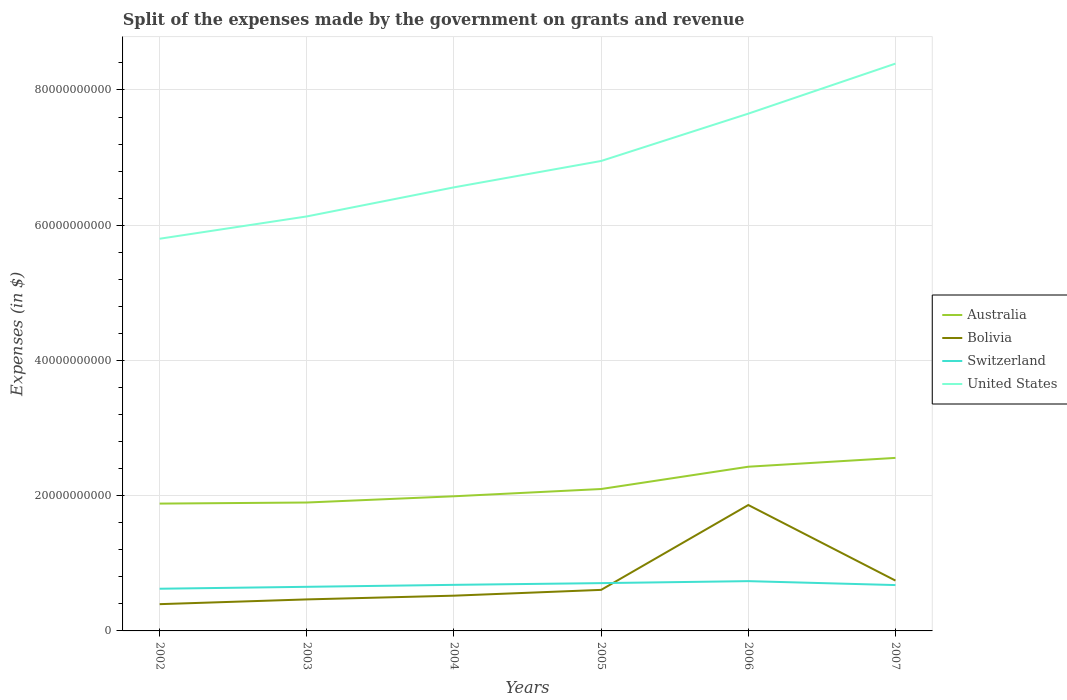Is the number of lines equal to the number of legend labels?
Provide a succinct answer. Yes. Across all years, what is the maximum expenses made by the government on grants and revenue in Switzerland?
Keep it short and to the point. 6.24e+09. What is the total expenses made by the government on grants and revenue in Switzerland in the graph?
Offer a terse response. -8.38e+08. What is the difference between the highest and the second highest expenses made by the government on grants and revenue in Australia?
Provide a short and direct response. 6.76e+09. Is the expenses made by the government on grants and revenue in Australia strictly greater than the expenses made by the government on grants and revenue in Bolivia over the years?
Give a very brief answer. No. How many years are there in the graph?
Offer a terse response. 6. Does the graph contain any zero values?
Give a very brief answer. No. Where does the legend appear in the graph?
Keep it short and to the point. Center right. How many legend labels are there?
Keep it short and to the point. 4. How are the legend labels stacked?
Make the answer very short. Vertical. What is the title of the graph?
Provide a succinct answer. Split of the expenses made by the government on grants and revenue. What is the label or title of the X-axis?
Offer a terse response. Years. What is the label or title of the Y-axis?
Provide a succinct answer. Expenses (in $). What is the Expenses (in $) in Australia in 2002?
Keep it short and to the point. 1.88e+1. What is the Expenses (in $) of Bolivia in 2002?
Provide a short and direct response. 3.96e+09. What is the Expenses (in $) of Switzerland in 2002?
Your answer should be very brief. 6.24e+09. What is the Expenses (in $) of United States in 2002?
Give a very brief answer. 5.80e+1. What is the Expenses (in $) in Australia in 2003?
Give a very brief answer. 1.90e+1. What is the Expenses (in $) of Bolivia in 2003?
Keep it short and to the point. 4.66e+09. What is the Expenses (in $) of Switzerland in 2003?
Your answer should be very brief. 6.52e+09. What is the Expenses (in $) in United States in 2003?
Give a very brief answer. 6.13e+1. What is the Expenses (in $) of Australia in 2004?
Provide a short and direct response. 1.99e+1. What is the Expenses (in $) in Bolivia in 2004?
Make the answer very short. 5.21e+09. What is the Expenses (in $) in Switzerland in 2004?
Make the answer very short. 6.81e+09. What is the Expenses (in $) of United States in 2004?
Provide a short and direct response. 6.56e+1. What is the Expenses (in $) of Australia in 2005?
Provide a succinct answer. 2.10e+1. What is the Expenses (in $) in Bolivia in 2005?
Keep it short and to the point. 6.07e+09. What is the Expenses (in $) in Switzerland in 2005?
Your answer should be very brief. 7.07e+09. What is the Expenses (in $) of United States in 2005?
Your response must be concise. 6.95e+1. What is the Expenses (in $) in Australia in 2006?
Provide a succinct answer. 2.43e+1. What is the Expenses (in $) in Bolivia in 2006?
Ensure brevity in your answer.  1.86e+1. What is the Expenses (in $) in Switzerland in 2006?
Your response must be concise. 7.36e+09. What is the Expenses (in $) of United States in 2006?
Keep it short and to the point. 7.65e+1. What is the Expenses (in $) in Australia in 2007?
Provide a short and direct response. 2.56e+1. What is the Expenses (in $) of Bolivia in 2007?
Provide a short and direct response. 7.44e+09. What is the Expenses (in $) of Switzerland in 2007?
Give a very brief answer. 6.78e+09. What is the Expenses (in $) in United States in 2007?
Ensure brevity in your answer.  8.39e+1. Across all years, what is the maximum Expenses (in $) of Australia?
Offer a very short reply. 2.56e+1. Across all years, what is the maximum Expenses (in $) in Bolivia?
Keep it short and to the point. 1.86e+1. Across all years, what is the maximum Expenses (in $) of Switzerland?
Ensure brevity in your answer.  7.36e+09. Across all years, what is the maximum Expenses (in $) in United States?
Offer a terse response. 8.39e+1. Across all years, what is the minimum Expenses (in $) in Australia?
Ensure brevity in your answer.  1.88e+1. Across all years, what is the minimum Expenses (in $) in Bolivia?
Your answer should be very brief. 3.96e+09. Across all years, what is the minimum Expenses (in $) of Switzerland?
Your response must be concise. 6.24e+09. Across all years, what is the minimum Expenses (in $) in United States?
Keep it short and to the point. 5.80e+1. What is the total Expenses (in $) in Australia in the graph?
Make the answer very short. 1.29e+11. What is the total Expenses (in $) in Bolivia in the graph?
Your answer should be compact. 4.60e+1. What is the total Expenses (in $) of Switzerland in the graph?
Ensure brevity in your answer.  4.08e+1. What is the total Expenses (in $) in United States in the graph?
Your answer should be compact. 4.15e+11. What is the difference between the Expenses (in $) of Australia in 2002 and that in 2003?
Your answer should be very brief. -1.58e+08. What is the difference between the Expenses (in $) of Bolivia in 2002 and that in 2003?
Provide a succinct answer. -7.02e+08. What is the difference between the Expenses (in $) of Switzerland in 2002 and that in 2003?
Offer a very short reply. -2.84e+08. What is the difference between the Expenses (in $) in United States in 2002 and that in 2003?
Provide a succinct answer. -3.30e+09. What is the difference between the Expenses (in $) of Australia in 2002 and that in 2004?
Give a very brief answer. -1.08e+09. What is the difference between the Expenses (in $) of Bolivia in 2002 and that in 2004?
Provide a short and direct response. -1.26e+09. What is the difference between the Expenses (in $) in Switzerland in 2002 and that in 2004?
Your response must be concise. -5.74e+08. What is the difference between the Expenses (in $) of United States in 2002 and that in 2004?
Provide a short and direct response. -7.60e+09. What is the difference between the Expenses (in $) of Australia in 2002 and that in 2005?
Make the answer very short. -2.16e+09. What is the difference between the Expenses (in $) of Bolivia in 2002 and that in 2005?
Keep it short and to the point. -2.11e+09. What is the difference between the Expenses (in $) in Switzerland in 2002 and that in 2005?
Keep it short and to the point. -8.30e+08. What is the difference between the Expenses (in $) of United States in 2002 and that in 2005?
Provide a succinct answer. -1.15e+1. What is the difference between the Expenses (in $) of Australia in 2002 and that in 2006?
Provide a succinct answer. -5.45e+09. What is the difference between the Expenses (in $) in Bolivia in 2002 and that in 2006?
Make the answer very short. -1.47e+1. What is the difference between the Expenses (in $) of Switzerland in 2002 and that in 2006?
Offer a terse response. -1.12e+09. What is the difference between the Expenses (in $) of United States in 2002 and that in 2006?
Provide a short and direct response. -1.85e+1. What is the difference between the Expenses (in $) of Australia in 2002 and that in 2007?
Ensure brevity in your answer.  -6.76e+09. What is the difference between the Expenses (in $) in Bolivia in 2002 and that in 2007?
Offer a very short reply. -3.48e+09. What is the difference between the Expenses (in $) in Switzerland in 2002 and that in 2007?
Offer a very short reply. -5.41e+08. What is the difference between the Expenses (in $) in United States in 2002 and that in 2007?
Your response must be concise. -2.59e+1. What is the difference between the Expenses (in $) in Australia in 2003 and that in 2004?
Keep it short and to the point. -9.24e+08. What is the difference between the Expenses (in $) of Bolivia in 2003 and that in 2004?
Make the answer very short. -5.53e+08. What is the difference between the Expenses (in $) of Switzerland in 2003 and that in 2004?
Your answer should be very brief. -2.91e+08. What is the difference between the Expenses (in $) of United States in 2003 and that in 2004?
Give a very brief answer. -4.30e+09. What is the difference between the Expenses (in $) in Australia in 2003 and that in 2005?
Make the answer very short. -2.00e+09. What is the difference between the Expenses (in $) in Bolivia in 2003 and that in 2005?
Your answer should be compact. -1.41e+09. What is the difference between the Expenses (in $) in Switzerland in 2003 and that in 2005?
Your response must be concise. -5.46e+08. What is the difference between the Expenses (in $) in United States in 2003 and that in 2005?
Your answer should be compact. -8.20e+09. What is the difference between the Expenses (in $) of Australia in 2003 and that in 2006?
Offer a very short reply. -5.29e+09. What is the difference between the Expenses (in $) of Bolivia in 2003 and that in 2006?
Your response must be concise. -1.40e+1. What is the difference between the Expenses (in $) of Switzerland in 2003 and that in 2006?
Your answer should be compact. -8.38e+08. What is the difference between the Expenses (in $) of United States in 2003 and that in 2006?
Offer a very short reply. -1.52e+1. What is the difference between the Expenses (in $) of Australia in 2003 and that in 2007?
Make the answer very short. -6.60e+09. What is the difference between the Expenses (in $) of Bolivia in 2003 and that in 2007?
Give a very brief answer. -2.78e+09. What is the difference between the Expenses (in $) in Switzerland in 2003 and that in 2007?
Provide a succinct answer. -2.58e+08. What is the difference between the Expenses (in $) in United States in 2003 and that in 2007?
Offer a terse response. -2.26e+1. What is the difference between the Expenses (in $) in Australia in 2004 and that in 2005?
Your response must be concise. -1.07e+09. What is the difference between the Expenses (in $) of Bolivia in 2004 and that in 2005?
Your response must be concise. -8.57e+08. What is the difference between the Expenses (in $) of Switzerland in 2004 and that in 2005?
Make the answer very short. -2.56e+08. What is the difference between the Expenses (in $) of United States in 2004 and that in 2005?
Your answer should be compact. -3.90e+09. What is the difference between the Expenses (in $) of Australia in 2004 and that in 2006?
Offer a terse response. -4.37e+09. What is the difference between the Expenses (in $) in Bolivia in 2004 and that in 2006?
Provide a succinct answer. -1.34e+1. What is the difference between the Expenses (in $) in Switzerland in 2004 and that in 2006?
Ensure brevity in your answer.  -5.47e+08. What is the difference between the Expenses (in $) in United States in 2004 and that in 2006?
Your answer should be compact. -1.09e+1. What is the difference between the Expenses (in $) of Australia in 2004 and that in 2007?
Give a very brief answer. -5.68e+09. What is the difference between the Expenses (in $) of Bolivia in 2004 and that in 2007?
Offer a terse response. -2.23e+09. What is the difference between the Expenses (in $) in Switzerland in 2004 and that in 2007?
Your response must be concise. 3.30e+07. What is the difference between the Expenses (in $) in United States in 2004 and that in 2007?
Offer a very short reply. -1.83e+1. What is the difference between the Expenses (in $) in Australia in 2005 and that in 2006?
Offer a terse response. -3.30e+09. What is the difference between the Expenses (in $) in Bolivia in 2005 and that in 2006?
Your answer should be very brief. -1.25e+1. What is the difference between the Expenses (in $) of Switzerland in 2005 and that in 2006?
Make the answer very short. -2.92e+08. What is the difference between the Expenses (in $) of United States in 2005 and that in 2006?
Ensure brevity in your answer.  -7.00e+09. What is the difference between the Expenses (in $) in Australia in 2005 and that in 2007?
Your response must be concise. -4.60e+09. What is the difference between the Expenses (in $) in Bolivia in 2005 and that in 2007?
Ensure brevity in your answer.  -1.37e+09. What is the difference between the Expenses (in $) of Switzerland in 2005 and that in 2007?
Keep it short and to the point. 2.89e+08. What is the difference between the Expenses (in $) of United States in 2005 and that in 2007?
Provide a succinct answer. -1.44e+1. What is the difference between the Expenses (in $) in Australia in 2006 and that in 2007?
Provide a short and direct response. -1.31e+09. What is the difference between the Expenses (in $) of Bolivia in 2006 and that in 2007?
Give a very brief answer. 1.12e+1. What is the difference between the Expenses (in $) in Switzerland in 2006 and that in 2007?
Offer a very short reply. 5.80e+08. What is the difference between the Expenses (in $) in United States in 2006 and that in 2007?
Ensure brevity in your answer.  -7.40e+09. What is the difference between the Expenses (in $) of Australia in 2002 and the Expenses (in $) of Bolivia in 2003?
Offer a terse response. 1.42e+1. What is the difference between the Expenses (in $) in Australia in 2002 and the Expenses (in $) in Switzerland in 2003?
Your response must be concise. 1.23e+1. What is the difference between the Expenses (in $) of Australia in 2002 and the Expenses (in $) of United States in 2003?
Offer a terse response. -4.25e+1. What is the difference between the Expenses (in $) in Bolivia in 2002 and the Expenses (in $) in Switzerland in 2003?
Your answer should be very brief. -2.56e+09. What is the difference between the Expenses (in $) of Bolivia in 2002 and the Expenses (in $) of United States in 2003?
Offer a terse response. -5.73e+1. What is the difference between the Expenses (in $) in Switzerland in 2002 and the Expenses (in $) in United States in 2003?
Provide a short and direct response. -5.51e+1. What is the difference between the Expenses (in $) of Australia in 2002 and the Expenses (in $) of Bolivia in 2004?
Your answer should be compact. 1.36e+1. What is the difference between the Expenses (in $) in Australia in 2002 and the Expenses (in $) in Switzerland in 2004?
Your answer should be very brief. 1.20e+1. What is the difference between the Expenses (in $) of Australia in 2002 and the Expenses (in $) of United States in 2004?
Offer a very short reply. -4.68e+1. What is the difference between the Expenses (in $) in Bolivia in 2002 and the Expenses (in $) in Switzerland in 2004?
Provide a short and direct response. -2.86e+09. What is the difference between the Expenses (in $) of Bolivia in 2002 and the Expenses (in $) of United States in 2004?
Provide a succinct answer. -6.16e+1. What is the difference between the Expenses (in $) in Switzerland in 2002 and the Expenses (in $) in United States in 2004?
Offer a terse response. -5.94e+1. What is the difference between the Expenses (in $) in Australia in 2002 and the Expenses (in $) in Bolivia in 2005?
Offer a very short reply. 1.28e+1. What is the difference between the Expenses (in $) of Australia in 2002 and the Expenses (in $) of Switzerland in 2005?
Your answer should be compact. 1.18e+1. What is the difference between the Expenses (in $) of Australia in 2002 and the Expenses (in $) of United States in 2005?
Your answer should be compact. -5.07e+1. What is the difference between the Expenses (in $) of Bolivia in 2002 and the Expenses (in $) of Switzerland in 2005?
Keep it short and to the point. -3.11e+09. What is the difference between the Expenses (in $) of Bolivia in 2002 and the Expenses (in $) of United States in 2005?
Give a very brief answer. -6.55e+1. What is the difference between the Expenses (in $) in Switzerland in 2002 and the Expenses (in $) in United States in 2005?
Ensure brevity in your answer.  -6.33e+1. What is the difference between the Expenses (in $) of Australia in 2002 and the Expenses (in $) of Bolivia in 2006?
Make the answer very short. 2.11e+08. What is the difference between the Expenses (in $) of Australia in 2002 and the Expenses (in $) of Switzerland in 2006?
Your answer should be very brief. 1.15e+1. What is the difference between the Expenses (in $) of Australia in 2002 and the Expenses (in $) of United States in 2006?
Your response must be concise. -5.77e+1. What is the difference between the Expenses (in $) in Bolivia in 2002 and the Expenses (in $) in Switzerland in 2006?
Make the answer very short. -3.40e+09. What is the difference between the Expenses (in $) in Bolivia in 2002 and the Expenses (in $) in United States in 2006?
Give a very brief answer. -7.25e+1. What is the difference between the Expenses (in $) of Switzerland in 2002 and the Expenses (in $) of United States in 2006?
Make the answer very short. -7.03e+1. What is the difference between the Expenses (in $) of Australia in 2002 and the Expenses (in $) of Bolivia in 2007?
Your answer should be very brief. 1.14e+1. What is the difference between the Expenses (in $) in Australia in 2002 and the Expenses (in $) in Switzerland in 2007?
Provide a succinct answer. 1.21e+1. What is the difference between the Expenses (in $) in Australia in 2002 and the Expenses (in $) in United States in 2007?
Keep it short and to the point. -6.51e+1. What is the difference between the Expenses (in $) in Bolivia in 2002 and the Expenses (in $) in Switzerland in 2007?
Offer a terse response. -2.82e+09. What is the difference between the Expenses (in $) in Bolivia in 2002 and the Expenses (in $) in United States in 2007?
Provide a succinct answer. -7.99e+1. What is the difference between the Expenses (in $) in Switzerland in 2002 and the Expenses (in $) in United States in 2007?
Offer a terse response. -7.77e+1. What is the difference between the Expenses (in $) of Australia in 2003 and the Expenses (in $) of Bolivia in 2004?
Make the answer very short. 1.38e+1. What is the difference between the Expenses (in $) in Australia in 2003 and the Expenses (in $) in Switzerland in 2004?
Your response must be concise. 1.22e+1. What is the difference between the Expenses (in $) of Australia in 2003 and the Expenses (in $) of United States in 2004?
Your answer should be very brief. -4.66e+1. What is the difference between the Expenses (in $) in Bolivia in 2003 and the Expenses (in $) in Switzerland in 2004?
Make the answer very short. -2.15e+09. What is the difference between the Expenses (in $) in Bolivia in 2003 and the Expenses (in $) in United States in 2004?
Give a very brief answer. -6.09e+1. What is the difference between the Expenses (in $) of Switzerland in 2003 and the Expenses (in $) of United States in 2004?
Ensure brevity in your answer.  -5.91e+1. What is the difference between the Expenses (in $) in Australia in 2003 and the Expenses (in $) in Bolivia in 2005?
Offer a very short reply. 1.29e+1. What is the difference between the Expenses (in $) of Australia in 2003 and the Expenses (in $) of Switzerland in 2005?
Ensure brevity in your answer.  1.19e+1. What is the difference between the Expenses (in $) in Australia in 2003 and the Expenses (in $) in United States in 2005?
Provide a succinct answer. -5.05e+1. What is the difference between the Expenses (in $) of Bolivia in 2003 and the Expenses (in $) of Switzerland in 2005?
Provide a succinct answer. -2.41e+09. What is the difference between the Expenses (in $) of Bolivia in 2003 and the Expenses (in $) of United States in 2005?
Keep it short and to the point. -6.48e+1. What is the difference between the Expenses (in $) of Switzerland in 2003 and the Expenses (in $) of United States in 2005?
Keep it short and to the point. -6.30e+1. What is the difference between the Expenses (in $) of Australia in 2003 and the Expenses (in $) of Bolivia in 2006?
Provide a short and direct response. 3.69e+08. What is the difference between the Expenses (in $) in Australia in 2003 and the Expenses (in $) in Switzerland in 2006?
Offer a very short reply. 1.16e+1. What is the difference between the Expenses (in $) in Australia in 2003 and the Expenses (in $) in United States in 2006?
Your response must be concise. -5.75e+1. What is the difference between the Expenses (in $) in Bolivia in 2003 and the Expenses (in $) in Switzerland in 2006?
Your answer should be very brief. -2.70e+09. What is the difference between the Expenses (in $) in Bolivia in 2003 and the Expenses (in $) in United States in 2006?
Give a very brief answer. -7.18e+1. What is the difference between the Expenses (in $) in Switzerland in 2003 and the Expenses (in $) in United States in 2006?
Your answer should be compact. -7.00e+1. What is the difference between the Expenses (in $) in Australia in 2003 and the Expenses (in $) in Bolivia in 2007?
Ensure brevity in your answer.  1.15e+1. What is the difference between the Expenses (in $) of Australia in 2003 and the Expenses (in $) of Switzerland in 2007?
Your answer should be compact. 1.22e+1. What is the difference between the Expenses (in $) of Australia in 2003 and the Expenses (in $) of United States in 2007?
Offer a terse response. -6.49e+1. What is the difference between the Expenses (in $) in Bolivia in 2003 and the Expenses (in $) in Switzerland in 2007?
Your answer should be very brief. -2.12e+09. What is the difference between the Expenses (in $) in Bolivia in 2003 and the Expenses (in $) in United States in 2007?
Your answer should be compact. -7.92e+1. What is the difference between the Expenses (in $) in Switzerland in 2003 and the Expenses (in $) in United States in 2007?
Offer a very short reply. -7.74e+1. What is the difference between the Expenses (in $) in Australia in 2004 and the Expenses (in $) in Bolivia in 2005?
Provide a succinct answer. 1.38e+1. What is the difference between the Expenses (in $) of Australia in 2004 and the Expenses (in $) of Switzerland in 2005?
Make the answer very short. 1.28e+1. What is the difference between the Expenses (in $) in Australia in 2004 and the Expenses (in $) in United States in 2005?
Your response must be concise. -4.96e+1. What is the difference between the Expenses (in $) in Bolivia in 2004 and the Expenses (in $) in Switzerland in 2005?
Your answer should be compact. -1.86e+09. What is the difference between the Expenses (in $) in Bolivia in 2004 and the Expenses (in $) in United States in 2005?
Provide a short and direct response. -6.43e+1. What is the difference between the Expenses (in $) in Switzerland in 2004 and the Expenses (in $) in United States in 2005?
Give a very brief answer. -6.27e+1. What is the difference between the Expenses (in $) of Australia in 2004 and the Expenses (in $) of Bolivia in 2006?
Your answer should be very brief. 1.29e+09. What is the difference between the Expenses (in $) of Australia in 2004 and the Expenses (in $) of Switzerland in 2006?
Your response must be concise. 1.26e+1. What is the difference between the Expenses (in $) of Australia in 2004 and the Expenses (in $) of United States in 2006?
Your answer should be very brief. -5.66e+1. What is the difference between the Expenses (in $) in Bolivia in 2004 and the Expenses (in $) in Switzerland in 2006?
Offer a very short reply. -2.15e+09. What is the difference between the Expenses (in $) of Bolivia in 2004 and the Expenses (in $) of United States in 2006?
Your response must be concise. -7.13e+1. What is the difference between the Expenses (in $) of Switzerland in 2004 and the Expenses (in $) of United States in 2006?
Ensure brevity in your answer.  -6.97e+1. What is the difference between the Expenses (in $) of Australia in 2004 and the Expenses (in $) of Bolivia in 2007?
Ensure brevity in your answer.  1.25e+1. What is the difference between the Expenses (in $) of Australia in 2004 and the Expenses (in $) of Switzerland in 2007?
Ensure brevity in your answer.  1.31e+1. What is the difference between the Expenses (in $) in Australia in 2004 and the Expenses (in $) in United States in 2007?
Give a very brief answer. -6.40e+1. What is the difference between the Expenses (in $) in Bolivia in 2004 and the Expenses (in $) in Switzerland in 2007?
Provide a succinct answer. -1.57e+09. What is the difference between the Expenses (in $) in Bolivia in 2004 and the Expenses (in $) in United States in 2007?
Offer a very short reply. -7.87e+1. What is the difference between the Expenses (in $) of Switzerland in 2004 and the Expenses (in $) of United States in 2007?
Provide a short and direct response. -7.71e+1. What is the difference between the Expenses (in $) in Australia in 2005 and the Expenses (in $) in Bolivia in 2006?
Your answer should be compact. 2.37e+09. What is the difference between the Expenses (in $) of Australia in 2005 and the Expenses (in $) of Switzerland in 2006?
Offer a terse response. 1.36e+1. What is the difference between the Expenses (in $) in Australia in 2005 and the Expenses (in $) in United States in 2006?
Ensure brevity in your answer.  -5.55e+1. What is the difference between the Expenses (in $) of Bolivia in 2005 and the Expenses (in $) of Switzerland in 2006?
Ensure brevity in your answer.  -1.29e+09. What is the difference between the Expenses (in $) in Bolivia in 2005 and the Expenses (in $) in United States in 2006?
Make the answer very short. -7.04e+1. What is the difference between the Expenses (in $) of Switzerland in 2005 and the Expenses (in $) of United States in 2006?
Your response must be concise. -6.94e+1. What is the difference between the Expenses (in $) of Australia in 2005 and the Expenses (in $) of Bolivia in 2007?
Your answer should be compact. 1.35e+1. What is the difference between the Expenses (in $) in Australia in 2005 and the Expenses (in $) in Switzerland in 2007?
Your response must be concise. 1.42e+1. What is the difference between the Expenses (in $) in Australia in 2005 and the Expenses (in $) in United States in 2007?
Keep it short and to the point. -6.29e+1. What is the difference between the Expenses (in $) in Bolivia in 2005 and the Expenses (in $) in Switzerland in 2007?
Give a very brief answer. -7.10e+08. What is the difference between the Expenses (in $) in Bolivia in 2005 and the Expenses (in $) in United States in 2007?
Offer a terse response. -7.78e+1. What is the difference between the Expenses (in $) of Switzerland in 2005 and the Expenses (in $) of United States in 2007?
Make the answer very short. -7.68e+1. What is the difference between the Expenses (in $) of Australia in 2006 and the Expenses (in $) of Bolivia in 2007?
Your answer should be compact. 1.68e+1. What is the difference between the Expenses (in $) of Australia in 2006 and the Expenses (in $) of Switzerland in 2007?
Offer a terse response. 1.75e+1. What is the difference between the Expenses (in $) in Australia in 2006 and the Expenses (in $) in United States in 2007?
Your answer should be compact. -5.96e+1. What is the difference between the Expenses (in $) in Bolivia in 2006 and the Expenses (in $) in Switzerland in 2007?
Ensure brevity in your answer.  1.18e+1. What is the difference between the Expenses (in $) of Bolivia in 2006 and the Expenses (in $) of United States in 2007?
Your answer should be very brief. -6.53e+1. What is the difference between the Expenses (in $) in Switzerland in 2006 and the Expenses (in $) in United States in 2007?
Offer a very short reply. -7.65e+1. What is the average Expenses (in $) of Australia per year?
Provide a short and direct response. 2.14e+1. What is the average Expenses (in $) in Bolivia per year?
Your response must be concise. 7.66e+09. What is the average Expenses (in $) of Switzerland per year?
Make the answer very short. 6.80e+09. What is the average Expenses (in $) of United States per year?
Your response must be concise. 6.91e+1. In the year 2002, what is the difference between the Expenses (in $) of Australia and Expenses (in $) of Bolivia?
Ensure brevity in your answer.  1.49e+1. In the year 2002, what is the difference between the Expenses (in $) in Australia and Expenses (in $) in Switzerland?
Your response must be concise. 1.26e+1. In the year 2002, what is the difference between the Expenses (in $) in Australia and Expenses (in $) in United States?
Your response must be concise. -3.92e+1. In the year 2002, what is the difference between the Expenses (in $) in Bolivia and Expenses (in $) in Switzerland?
Provide a short and direct response. -2.28e+09. In the year 2002, what is the difference between the Expenses (in $) in Bolivia and Expenses (in $) in United States?
Provide a short and direct response. -5.40e+1. In the year 2002, what is the difference between the Expenses (in $) of Switzerland and Expenses (in $) of United States?
Make the answer very short. -5.18e+1. In the year 2003, what is the difference between the Expenses (in $) of Australia and Expenses (in $) of Bolivia?
Your answer should be compact. 1.43e+1. In the year 2003, what is the difference between the Expenses (in $) of Australia and Expenses (in $) of Switzerland?
Make the answer very short. 1.25e+1. In the year 2003, what is the difference between the Expenses (in $) of Australia and Expenses (in $) of United States?
Your answer should be very brief. -4.23e+1. In the year 2003, what is the difference between the Expenses (in $) in Bolivia and Expenses (in $) in Switzerland?
Offer a very short reply. -1.86e+09. In the year 2003, what is the difference between the Expenses (in $) in Bolivia and Expenses (in $) in United States?
Offer a terse response. -5.66e+1. In the year 2003, what is the difference between the Expenses (in $) of Switzerland and Expenses (in $) of United States?
Provide a short and direct response. -5.48e+1. In the year 2004, what is the difference between the Expenses (in $) in Australia and Expenses (in $) in Bolivia?
Keep it short and to the point. 1.47e+1. In the year 2004, what is the difference between the Expenses (in $) in Australia and Expenses (in $) in Switzerland?
Provide a short and direct response. 1.31e+1. In the year 2004, what is the difference between the Expenses (in $) in Australia and Expenses (in $) in United States?
Your answer should be very brief. -4.57e+1. In the year 2004, what is the difference between the Expenses (in $) in Bolivia and Expenses (in $) in Switzerland?
Provide a short and direct response. -1.60e+09. In the year 2004, what is the difference between the Expenses (in $) in Bolivia and Expenses (in $) in United States?
Offer a terse response. -6.04e+1. In the year 2004, what is the difference between the Expenses (in $) in Switzerland and Expenses (in $) in United States?
Your response must be concise. -5.88e+1. In the year 2005, what is the difference between the Expenses (in $) in Australia and Expenses (in $) in Bolivia?
Your response must be concise. 1.49e+1. In the year 2005, what is the difference between the Expenses (in $) in Australia and Expenses (in $) in Switzerland?
Keep it short and to the point. 1.39e+1. In the year 2005, what is the difference between the Expenses (in $) in Australia and Expenses (in $) in United States?
Your answer should be compact. -4.85e+1. In the year 2005, what is the difference between the Expenses (in $) of Bolivia and Expenses (in $) of Switzerland?
Your answer should be compact. -9.99e+08. In the year 2005, what is the difference between the Expenses (in $) of Bolivia and Expenses (in $) of United States?
Make the answer very short. -6.34e+1. In the year 2005, what is the difference between the Expenses (in $) in Switzerland and Expenses (in $) in United States?
Your answer should be very brief. -6.24e+1. In the year 2006, what is the difference between the Expenses (in $) of Australia and Expenses (in $) of Bolivia?
Your answer should be compact. 5.66e+09. In the year 2006, what is the difference between the Expenses (in $) in Australia and Expenses (in $) in Switzerland?
Ensure brevity in your answer.  1.69e+1. In the year 2006, what is the difference between the Expenses (in $) of Australia and Expenses (in $) of United States?
Keep it short and to the point. -5.22e+1. In the year 2006, what is the difference between the Expenses (in $) in Bolivia and Expenses (in $) in Switzerland?
Offer a very short reply. 1.13e+1. In the year 2006, what is the difference between the Expenses (in $) of Bolivia and Expenses (in $) of United States?
Your answer should be very brief. -5.79e+1. In the year 2006, what is the difference between the Expenses (in $) of Switzerland and Expenses (in $) of United States?
Your answer should be very brief. -6.91e+1. In the year 2007, what is the difference between the Expenses (in $) of Australia and Expenses (in $) of Bolivia?
Offer a terse response. 1.81e+1. In the year 2007, what is the difference between the Expenses (in $) of Australia and Expenses (in $) of Switzerland?
Make the answer very short. 1.88e+1. In the year 2007, what is the difference between the Expenses (in $) of Australia and Expenses (in $) of United States?
Make the answer very short. -5.83e+1. In the year 2007, what is the difference between the Expenses (in $) in Bolivia and Expenses (in $) in Switzerland?
Ensure brevity in your answer.  6.61e+08. In the year 2007, what is the difference between the Expenses (in $) of Bolivia and Expenses (in $) of United States?
Your answer should be very brief. -7.65e+1. In the year 2007, what is the difference between the Expenses (in $) of Switzerland and Expenses (in $) of United States?
Make the answer very short. -7.71e+1. What is the ratio of the Expenses (in $) in Australia in 2002 to that in 2003?
Provide a succinct answer. 0.99. What is the ratio of the Expenses (in $) in Bolivia in 2002 to that in 2003?
Offer a terse response. 0.85. What is the ratio of the Expenses (in $) in Switzerland in 2002 to that in 2003?
Provide a succinct answer. 0.96. What is the ratio of the Expenses (in $) of United States in 2002 to that in 2003?
Provide a short and direct response. 0.95. What is the ratio of the Expenses (in $) of Australia in 2002 to that in 2004?
Offer a terse response. 0.95. What is the ratio of the Expenses (in $) of Bolivia in 2002 to that in 2004?
Provide a short and direct response. 0.76. What is the ratio of the Expenses (in $) in Switzerland in 2002 to that in 2004?
Your answer should be compact. 0.92. What is the ratio of the Expenses (in $) in United States in 2002 to that in 2004?
Give a very brief answer. 0.88. What is the ratio of the Expenses (in $) of Australia in 2002 to that in 2005?
Offer a very short reply. 0.9. What is the ratio of the Expenses (in $) of Bolivia in 2002 to that in 2005?
Ensure brevity in your answer.  0.65. What is the ratio of the Expenses (in $) of Switzerland in 2002 to that in 2005?
Give a very brief answer. 0.88. What is the ratio of the Expenses (in $) of United States in 2002 to that in 2005?
Keep it short and to the point. 0.83. What is the ratio of the Expenses (in $) of Australia in 2002 to that in 2006?
Offer a very short reply. 0.78. What is the ratio of the Expenses (in $) of Bolivia in 2002 to that in 2006?
Offer a very short reply. 0.21. What is the ratio of the Expenses (in $) of Switzerland in 2002 to that in 2006?
Ensure brevity in your answer.  0.85. What is the ratio of the Expenses (in $) in United States in 2002 to that in 2006?
Offer a very short reply. 0.76. What is the ratio of the Expenses (in $) in Australia in 2002 to that in 2007?
Offer a very short reply. 0.74. What is the ratio of the Expenses (in $) of Bolivia in 2002 to that in 2007?
Your answer should be very brief. 0.53. What is the ratio of the Expenses (in $) in Switzerland in 2002 to that in 2007?
Provide a succinct answer. 0.92. What is the ratio of the Expenses (in $) in United States in 2002 to that in 2007?
Provide a short and direct response. 0.69. What is the ratio of the Expenses (in $) of Australia in 2003 to that in 2004?
Provide a short and direct response. 0.95. What is the ratio of the Expenses (in $) in Bolivia in 2003 to that in 2004?
Keep it short and to the point. 0.89. What is the ratio of the Expenses (in $) in Switzerland in 2003 to that in 2004?
Ensure brevity in your answer.  0.96. What is the ratio of the Expenses (in $) in United States in 2003 to that in 2004?
Provide a succinct answer. 0.93. What is the ratio of the Expenses (in $) of Australia in 2003 to that in 2005?
Keep it short and to the point. 0.9. What is the ratio of the Expenses (in $) of Bolivia in 2003 to that in 2005?
Offer a very short reply. 0.77. What is the ratio of the Expenses (in $) of Switzerland in 2003 to that in 2005?
Provide a succinct answer. 0.92. What is the ratio of the Expenses (in $) in United States in 2003 to that in 2005?
Ensure brevity in your answer.  0.88. What is the ratio of the Expenses (in $) of Australia in 2003 to that in 2006?
Offer a very short reply. 0.78. What is the ratio of the Expenses (in $) in Bolivia in 2003 to that in 2006?
Provide a short and direct response. 0.25. What is the ratio of the Expenses (in $) in Switzerland in 2003 to that in 2006?
Ensure brevity in your answer.  0.89. What is the ratio of the Expenses (in $) of United States in 2003 to that in 2006?
Ensure brevity in your answer.  0.8. What is the ratio of the Expenses (in $) in Australia in 2003 to that in 2007?
Offer a very short reply. 0.74. What is the ratio of the Expenses (in $) of Bolivia in 2003 to that in 2007?
Offer a terse response. 0.63. What is the ratio of the Expenses (in $) in United States in 2003 to that in 2007?
Offer a very short reply. 0.73. What is the ratio of the Expenses (in $) in Australia in 2004 to that in 2005?
Make the answer very short. 0.95. What is the ratio of the Expenses (in $) in Bolivia in 2004 to that in 2005?
Your answer should be compact. 0.86. What is the ratio of the Expenses (in $) of Switzerland in 2004 to that in 2005?
Offer a terse response. 0.96. What is the ratio of the Expenses (in $) of United States in 2004 to that in 2005?
Your response must be concise. 0.94. What is the ratio of the Expenses (in $) of Australia in 2004 to that in 2006?
Ensure brevity in your answer.  0.82. What is the ratio of the Expenses (in $) in Bolivia in 2004 to that in 2006?
Offer a very short reply. 0.28. What is the ratio of the Expenses (in $) in Switzerland in 2004 to that in 2006?
Make the answer very short. 0.93. What is the ratio of the Expenses (in $) of United States in 2004 to that in 2006?
Provide a short and direct response. 0.86. What is the ratio of the Expenses (in $) in Australia in 2004 to that in 2007?
Make the answer very short. 0.78. What is the ratio of the Expenses (in $) in Bolivia in 2004 to that in 2007?
Keep it short and to the point. 0.7. What is the ratio of the Expenses (in $) in Switzerland in 2004 to that in 2007?
Offer a very short reply. 1. What is the ratio of the Expenses (in $) of United States in 2004 to that in 2007?
Keep it short and to the point. 0.78. What is the ratio of the Expenses (in $) in Australia in 2005 to that in 2006?
Offer a very short reply. 0.86. What is the ratio of the Expenses (in $) of Bolivia in 2005 to that in 2006?
Your answer should be very brief. 0.33. What is the ratio of the Expenses (in $) in Switzerland in 2005 to that in 2006?
Your answer should be very brief. 0.96. What is the ratio of the Expenses (in $) of United States in 2005 to that in 2006?
Provide a short and direct response. 0.91. What is the ratio of the Expenses (in $) of Australia in 2005 to that in 2007?
Give a very brief answer. 0.82. What is the ratio of the Expenses (in $) in Bolivia in 2005 to that in 2007?
Your answer should be very brief. 0.82. What is the ratio of the Expenses (in $) of Switzerland in 2005 to that in 2007?
Provide a succinct answer. 1.04. What is the ratio of the Expenses (in $) of United States in 2005 to that in 2007?
Make the answer very short. 0.83. What is the ratio of the Expenses (in $) of Australia in 2006 to that in 2007?
Your answer should be compact. 0.95. What is the ratio of the Expenses (in $) in Bolivia in 2006 to that in 2007?
Keep it short and to the point. 2.5. What is the ratio of the Expenses (in $) of Switzerland in 2006 to that in 2007?
Make the answer very short. 1.09. What is the ratio of the Expenses (in $) of United States in 2006 to that in 2007?
Keep it short and to the point. 0.91. What is the difference between the highest and the second highest Expenses (in $) in Australia?
Offer a very short reply. 1.31e+09. What is the difference between the highest and the second highest Expenses (in $) of Bolivia?
Provide a short and direct response. 1.12e+1. What is the difference between the highest and the second highest Expenses (in $) of Switzerland?
Your response must be concise. 2.92e+08. What is the difference between the highest and the second highest Expenses (in $) in United States?
Make the answer very short. 7.40e+09. What is the difference between the highest and the lowest Expenses (in $) in Australia?
Provide a succinct answer. 6.76e+09. What is the difference between the highest and the lowest Expenses (in $) in Bolivia?
Provide a succinct answer. 1.47e+1. What is the difference between the highest and the lowest Expenses (in $) of Switzerland?
Provide a short and direct response. 1.12e+09. What is the difference between the highest and the lowest Expenses (in $) of United States?
Offer a terse response. 2.59e+1. 